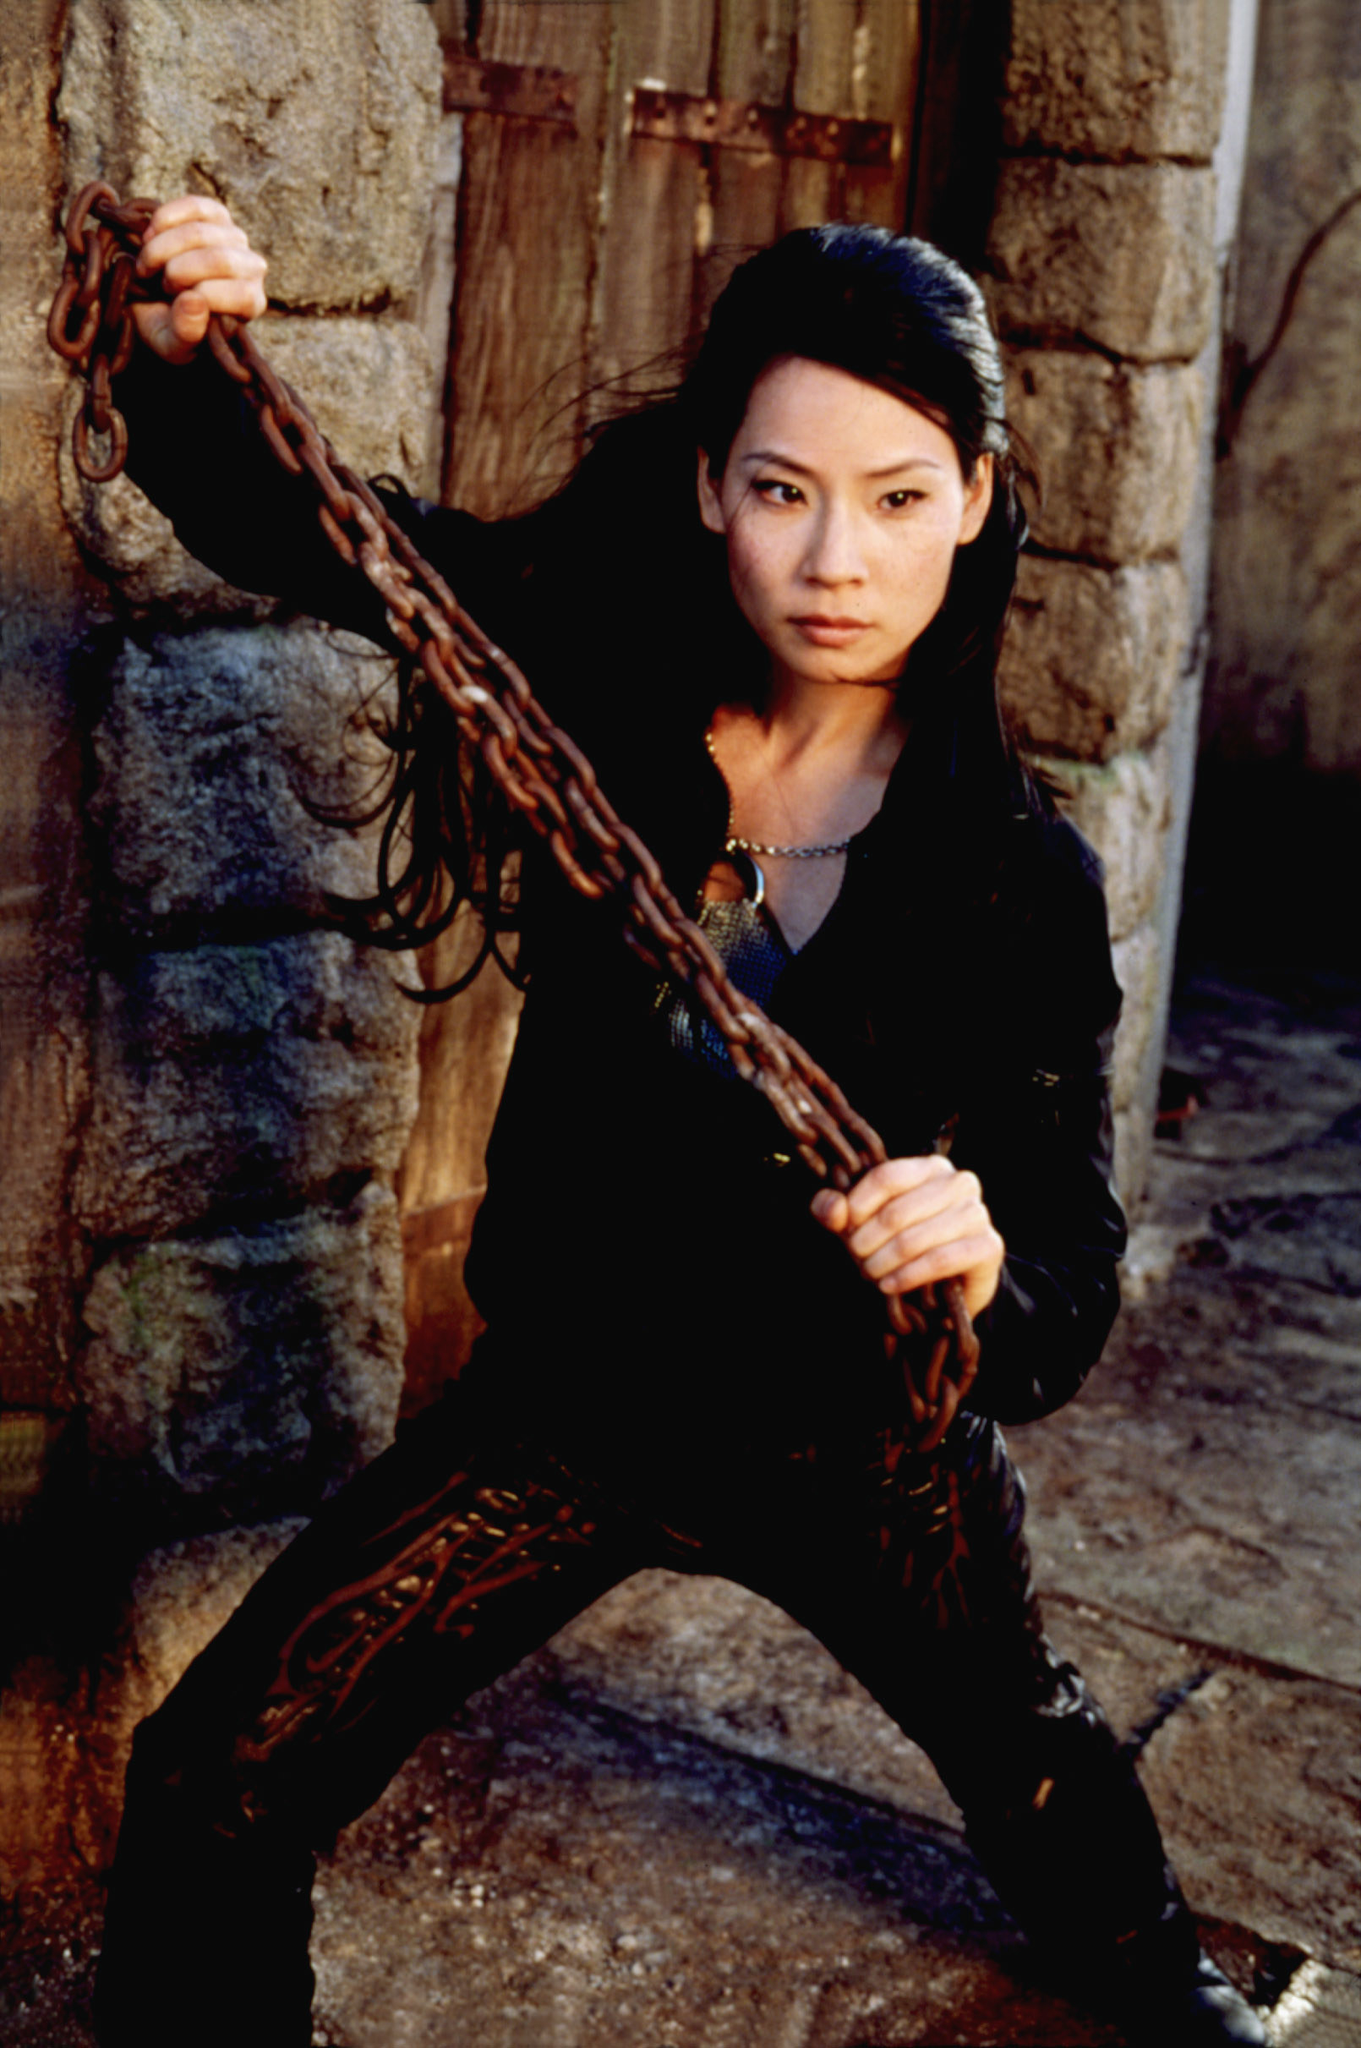What is this photo about? In the image, a character portrayed by an actress stands in a dynamic pose against an aged stone wall with a wooden door. She grips a heavy chain with her left hand, indicating readiness for action, while her right hand rests on her hip. Dressed entirely in black, the sleek outfit is accentuated by a bright red necklace around her neck. The stance and expression reflect determination and strength, capturing the essence of an intense moment. 